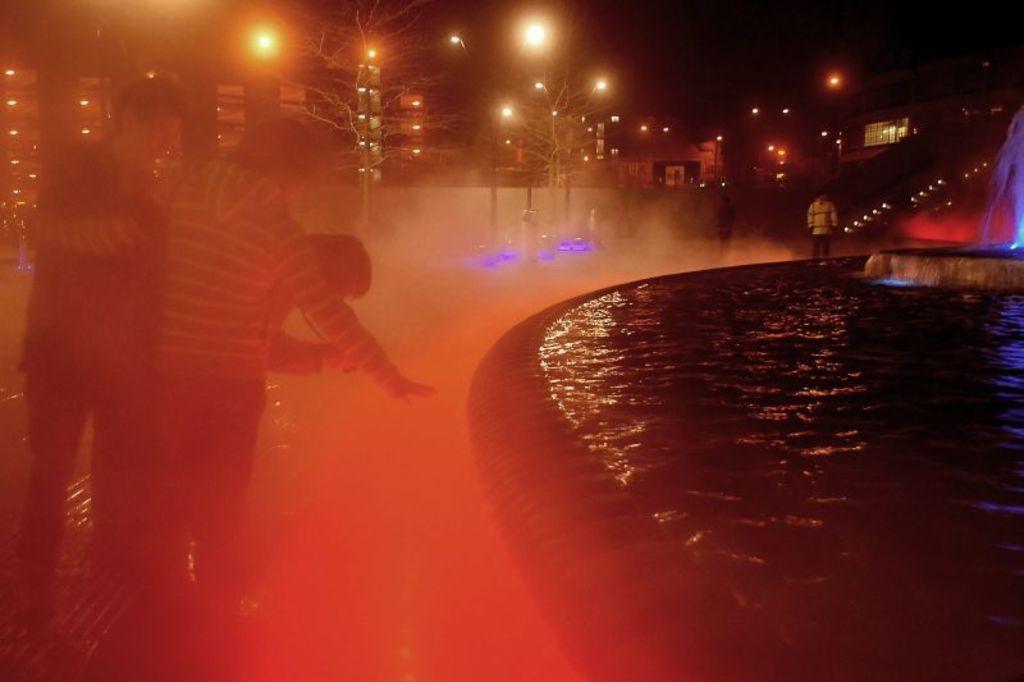How would you summarize this image in a sentence or two? In this image we can see a water fountain and some people standing and we can also see light poles and lights. 